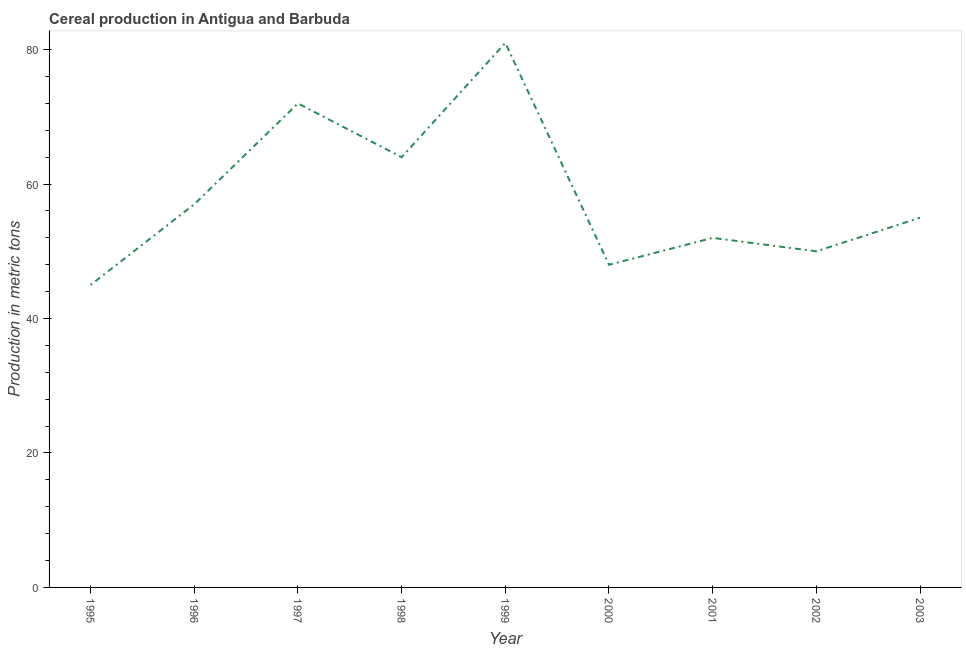What is the cereal production in 2002?
Ensure brevity in your answer.  50. Across all years, what is the maximum cereal production?
Your answer should be compact. 81. Across all years, what is the minimum cereal production?
Offer a terse response. 45. In which year was the cereal production maximum?
Make the answer very short. 1999. In which year was the cereal production minimum?
Offer a very short reply. 1995. What is the sum of the cereal production?
Your answer should be very brief. 524. What is the difference between the cereal production in 1998 and 2000?
Provide a succinct answer. 16. What is the average cereal production per year?
Your answer should be compact. 58.22. Do a majority of the years between 2003 and 2000 (inclusive) have cereal production greater than 40 metric tons?
Give a very brief answer. Yes. What is the ratio of the cereal production in 1998 to that in 2001?
Provide a short and direct response. 1.23. Is the cereal production in 1995 less than that in 1999?
Keep it short and to the point. Yes. What is the difference between the highest and the second highest cereal production?
Provide a short and direct response. 9. What is the difference between the highest and the lowest cereal production?
Keep it short and to the point. 36. In how many years, is the cereal production greater than the average cereal production taken over all years?
Keep it short and to the point. 3. Does the cereal production monotonically increase over the years?
Offer a very short reply. No. How many lines are there?
Your answer should be compact. 1. What is the difference between two consecutive major ticks on the Y-axis?
Offer a terse response. 20. What is the title of the graph?
Keep it short and to the point. Cereal production in Antigua and Barbuda. What is the label or title of the X-axis?
Offer a very short reply. Year. What is the label or title of the Y-axis?
Make the answer very short. Production in metric tons. What is the Production in metric tons in 1996?
Offer a terse response. 57. What is the Production in metric tons of 1997?
Provide a succinct answer. 72. What is the Production in metric tons in 2000?
Make the answer very short. 48. What is the Production in metric tons of 2003?
Keep it short and to the point. 55. What is the difference between the Production in metric tons in 1995 and 1996?
Your answer should be compact. -12. What is the difference between the Production in metric tons in 1995 and 1997?
Offer a very short reply. -27. What is the difference between the Production in metric tons in 1995 and 1999?
Provide a succinct answer. -36. What is the difference between the Production in metric tons in 1995 and 2002?
Offer a terse response. -5. What is the difference between the Production in metric tons in 1995 and 2003?
Keep it short and to the point. -10. What is the difference between the Production in metric tons in 1996 and 1998?
Keep it short and to the point. -7. What is the difference between the Production in metric tons in 1997 and 1998?
Your answer should be very brief. 8. What is the difference between the Production in metric tons in 1997 and 1999?
Your answer should be very brief. -9. What is the difference between the Production in metric tons in 1997 and 2000?
Your answer should be very brief. 24. What is the difference between the Production in metric tons in 1998 and 1999?
Your answer should be very brief. -17. What is the difference between the Production in metric tons in 1998 and 2002?
Provide a succinct answer. 14. What is the difference between the Production in metric tons in 1998 and 2003?
Ensure brevity in your answer.  9. What is the difference between the Production in metric tons in 1999 and 2001?
Your answer should be very brief. 29. What is the difference between the Production in metric tons in 1999 and 2003?
Offer a very short reply. 26. What is the difference between the Production in metric tons in 2000 and 2001?
Keep it short and to the point. -4. What is the difference between the Production in metric tons in 2000 and 2002?
Offer a very short reply. -2. What is the difference between the Production in metric tons in 2000 and 2003?
Ensure brevity in your answer.  -7. What is the difference between the Production in metric tons in 2001 and 2003?
Offer a terse response. -3. What is the difference between the Production in metric tons in 2002 and 2003?
Keep it short and to the point. -5. What is the ratio of the Production in metric tons in 1995 to that in 1996?
Offer a very short reply. 0.79. What is the ratio of the Production in metric tons in 1995 to that in 1997?
Your answer should be compact. 0.62. What is the ratio of the Production in metric tons in 1995 to that in 1998?
Offer a very short reply. 0.7. What is the ratio of the Production in metric tons in 1995 to that in 1999?
Make the answer very short. 0.56. What is the ratio of the Production in metric tons in 1995 to that in 2000?
Offer a terse response. 0.94. What is the ratio of the Production in metric tons in 1995 to that in 2001?
Offer a very short reply. 0.86. What is the ratio of the Production in metric tons in 1995 to that in 2002?
Provide a short and direct response. 0.9. What is the ratio of the Production in metric tons in 1995 to that in 2003?
Offer a terse response. 0.82. What is the ratio of the Production in metric tons in 1996 to that in 1997?
Your answer should be very brief. 0.79. What is the ratio of the Production in metric tons in 1996 to that in 1998?
Your response must be concise. 0.89. What is the ratio of the Production in metric tons in 1996 to that in 1999?
Keep it short and to the point. 0.7. What is the ratio of the Production in metric tons in 1996 to that in 2000?
Make the answer very short. 1.19. What is the ratio of the Production in metric tons in 1996 to that in 2001?
Offer a very short reply. 1.1. What is the ratio of the Production in metric tons in 1996 to that in 2002?
Keep it short and to the point. 1.14. What is the ratio of the Production in metric tons in 1996 to that in 2003?
Provide a short and direct response. 1.04. What is the ratio of the Production in metric tons in 1997 to that in 1998?
Keep it short and to the point. 1.12. What is the ratio of the Production in metric tons in 1997 to that in 1999?
Provide a succinct answer. 0.89. What is the ratio of the Production in metric tons in 1997 to that in 2001?
Make the answer very short. 1.39. What is the ratio of the Production in metric tons in 1997 to that in 2002?
Your answer should be very brief. 1.44. What is the ratio of the Production in metric tons in 1997 to that in 2003?
Make the answer very short. 1.31. What is the ratio of the Production in metric tons in 1998 to that in 1999?
Offer a terse response. 0.79. What is the ratio of the Production in metric tons in 1998 to that in 2000?
Give a very brief answer. 1.33. What is the ratio of the Production in metric tons in 1998 to that in 2001?
Your response must be concise. 1.23. What is the ratio of the Production in metric tons in 1998 to that in 2002?
Your response must be concise. 1.28. What is the ratio of the Production in metric tons in 1998 to that in 2003?
Your response must be concise. 1.16. What is the ratio of the Production in metric tons in 1999 to that in 2000?
Make the answer very short. 1.69. What is the ratio of the Production in metric tons in 1999 to that in 2001?
Offer a very short reply. 1.56. What is the ratio of the Production in metric tons in 1999 to that in 2002?
Your answer should be very brief. 1.62. What is the ratio of the Production in metric tons in 1999 to that in 2003?
Your answer should be very brief. 1.47. What is the ratio of the Production in metric tons in 2000 to that in 2001?
Offer a terse response. 0.92. What is the ratio of the Production in metric tons in 2000 to that in 2002?
Offer a terse response. 0.96. What is the ratio of the Production in metric tons in 2000 to that in 2003?
Provide a short and direct response. 0.87. What is the ratio of the Production in metric tons in 2001 to that in 2002?
Provide a succinct answer. 1.04. What is the ratio of the Production in metric tons in 2001 to that in 2003?
Ensure brevity in your answer.  0.94. What is the ratio of the Production in metric tons in 2002 to that in 2003?
Provide a succinct answer. 0.91. 